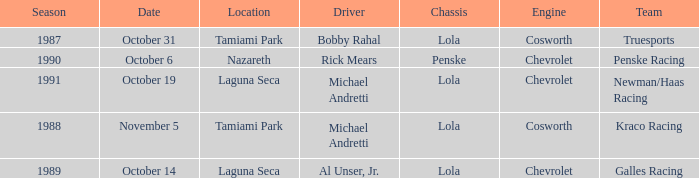What engine does Galles Racing use? Chevrolet. 